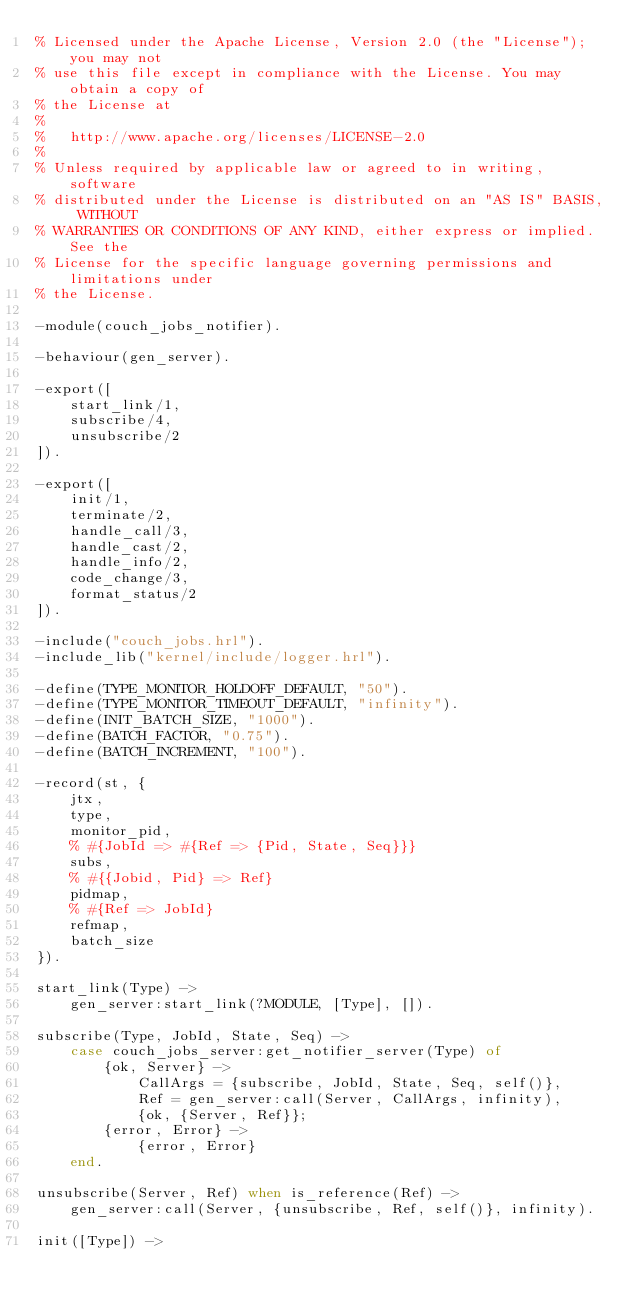Convert code to text. <code><loc_0><loc_0><loc_500><loc_500><_Erlang_>% Licensed under the Apache License, Version 2.0 (the "License"); you may not
% use this file except in compliance with the License. You may obtain a copy of
% the License at
%
%   http://www.apache.org/licenses/LICENSE-2.0
%
% Unless required by applicable law or agreed to in writing, software
% distributed under the License is distributed on an "AS IS" BASIS, WITHOUT
% WARRANTIES OR CONDITIONS OF ANY KIND, either express or implied. See the
% License for the specific language governing permissions and limitations under
% the License.

-module(couch_jobs_notifier).

-behaviour(gen_server).

-export([
    start_link/1,
    subscribe/4,
    unsubscribe/2
]).

-export([
    init/1,
    terminate/2,
    handle_call/3,
    handle_cast/2,
    handle_info/2,
    code_change/3,
    format_status/2
]).

-include("couch_jobs.hrl").
-include_lib("kernel/include/logger.hrl").

-define(TYPE_MONITOR_HOLDOFF_DEFAULT, "50").
-define(TYPE_MONITOR_TIMEOUT_DEFAULT, "infinity").
-define(INIT_BATCH_SIZE, "1000").
-define(BATCH_FACTOR, "0.75").
-define(BATCH_INCREMENT, "100").

-record(st, {
    jtx,
    type,
    monitor_pid,
    % #{JobId => #{Ref => {Pid, State, Seq}}}
    subs,
    % #{{Jobid, Pid} => Ref}
    pidmap,
    % #{Ref => JobId}
    refmap,
    batch_size
}).

start_link(Type) ->
    gen_server:start_link(?MODULE, [Type], []).

subscribe(Type, JobId, State, Seq) ->
    case couch_jobs_server:get_notifier_server(Type) of
        {ok, Server} ->
            CallArgs = {subscribe, JobId, State, Seq, self()},
            Ref = gen_server:call(Server, CallArgs, infinity),
            {ok, {Server, Ref}};
        {error, Error} ->
            {error, Error}
    end.

unsubscribe(Server, Ref) when is_reference(Ref) ->
    gen_server:call(Server, {unsubscribe, Ref, self()}, infinity).

init([Type]) -></code> 